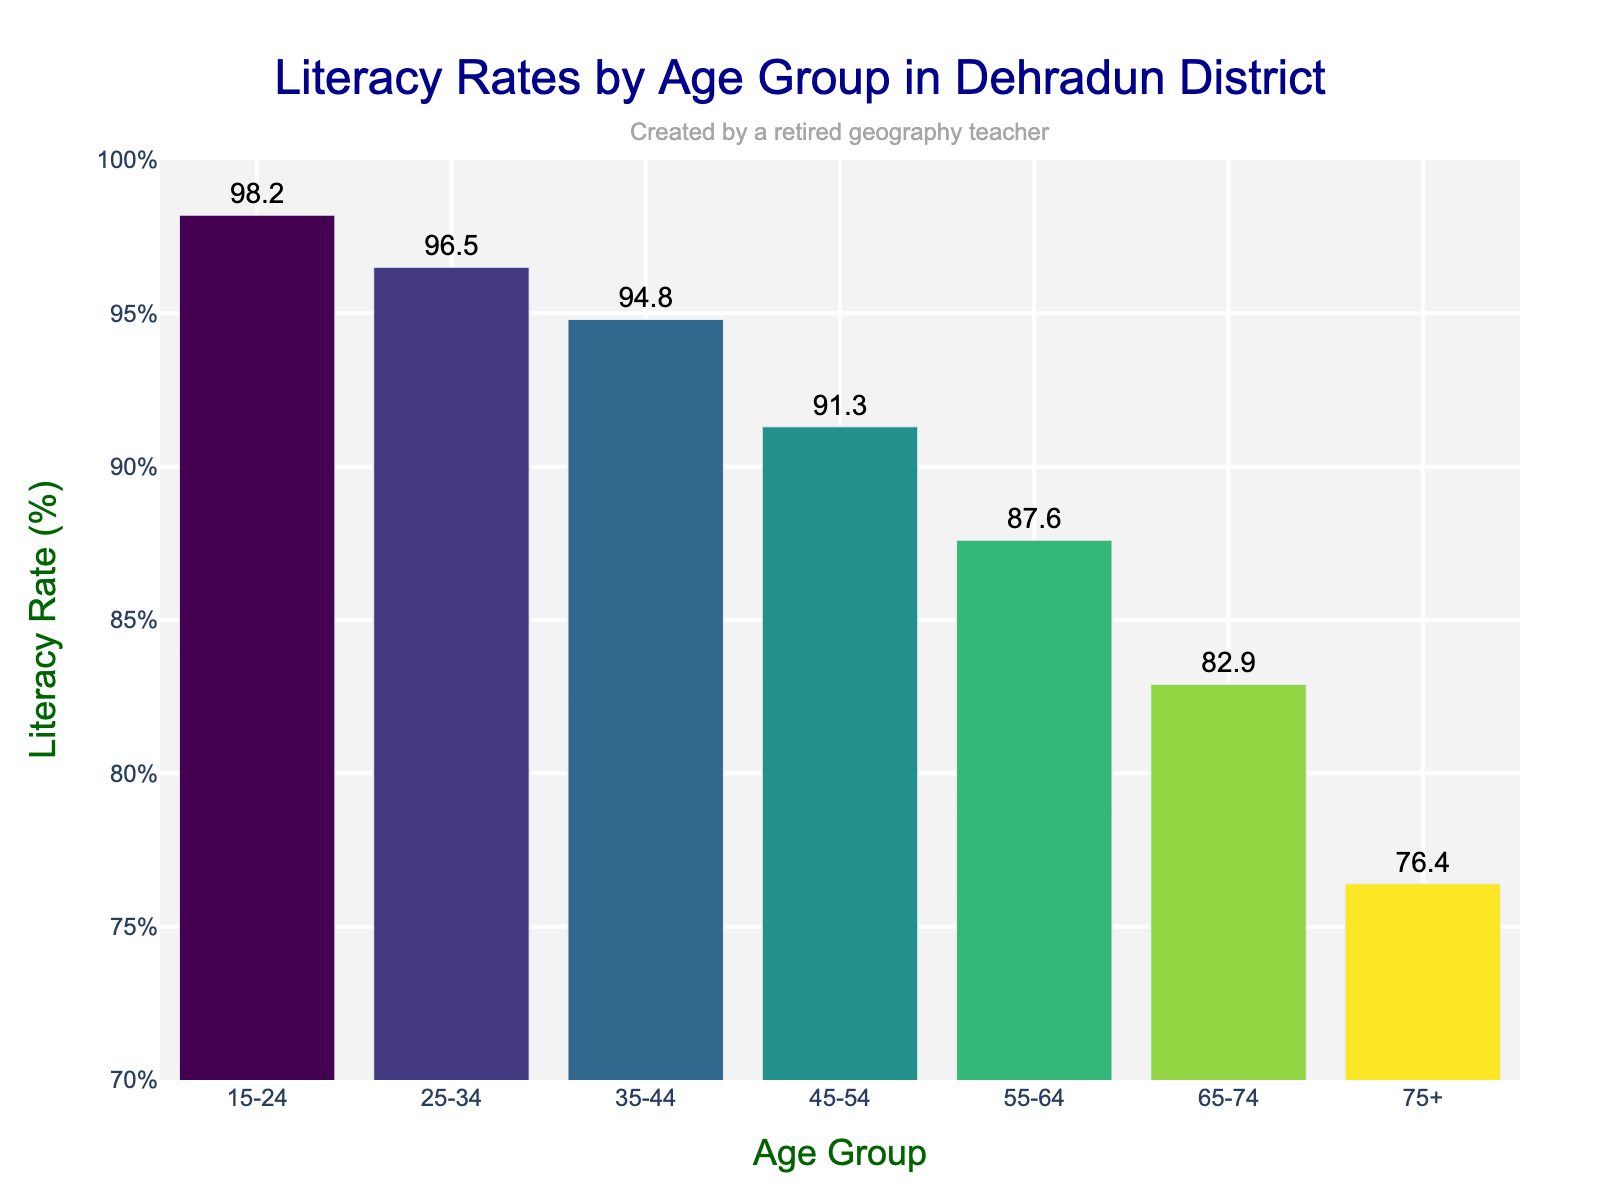Which age group has the highest literacy rate? The highest bar on the chart represents the age group 15-24, indicating that it has the highest literacy rate.
Answer: 15-24 How much lower is the literacy rate for the 75+ age group compared to the 15-24 age group? The literacy rate for the 75+ age group is 76.4%, and for the 15-24 age group, it is 98.2%. Subtracting these gives 98.2% - 76.4% = 21.8%.
Answer: 21.8% What's the difference in literacy rates between the 35-44 and 55-64 age groups? The literacy rates for the 35-44 and 55-64 age groups are 94.8% and 87.6% respectively. Subtracting these gives 94.8% - 87.6% = 7.2%.
Answer: 7.2% What is the average literacy rate for the age groups 45-54, 55-64, and 65-74? The literacy rates for 45-54, 55-64, and 65-74 are 91.3%, 87.6%, and 82.9% respectively. Adding these gives 91.3% + 87.6% + 82.9% = 261.8%. Dividing by 3 gives 261.8% / 3 = 87.27%.
Answer: 87.27% Which two consecutive age groups have the smallest difference in their literacy rates? By examining the differences between each pair of consecutive age groups: 15-24 to 25-34: 1.7%, 25-34 to 35-44: 1.7%, 35-44 to 45-54: 3.5%, 45-54 to 55-64: 3.7%, 55-64 to 65-74: 4.7%, 65-74 to 75+: 6.5%. The smallest differences are 1.7% between 15-24 and 25-34, and between 25-34 and 35-44.
Answer: 15-24 and 25-34 What is the median literacy rate among all age groups? The literacy rates in ascending order are: 76.4%, 82.9%, 87.6%, 91.3%, 94.8%, 96.5%, 98.2%. The median is the middle value, which is 91.3%.
Answer: 91.3% How does the literacy rate trend change as the age groups get older? The trend shows a generally decreasing literacy rate as the age groups get older, with each older age group having a lower literacy rate than the younger group preceding it.
Answer: Decreases with age Which age group shows a literacy rate closest to 90%? By examining the bars, the 45-54 age group has a literacy rate of 91.3%, which is closest to 90%.
Answer: 45-54 What is the total sum of the literacy rates for all age groups combined? Adding each literacy rate: 98.2% + 96.5% + 94.8% + 91.3% + 87.6% + 82.9% + 76.4% = 627.7%.
Answer: 627.7% 